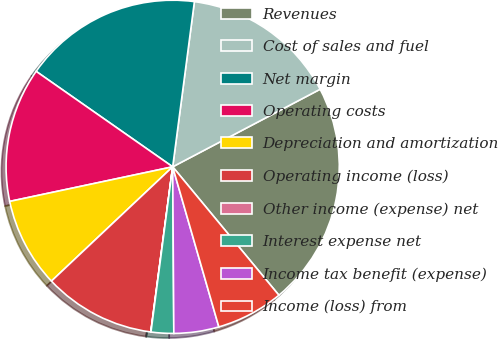Convert chart to OTSL. <chart><loc_0><loc_0><loc_500><loc_500><pie_chart><fcel>Revenues<fcel>Cost of sales and fuel<fcel>Net margin<fcel>Operating costs<fcel>Depreciation and amortization<fcel>Operating income (loss)<fcel>Other income (expense) net<fcel>Interest expense net<fcel>Income tax benefit (expense)<fcel>Income (loss) from<nl><fcel>21.71%<fcel>15.21%<fcel>17.37%<fcel>13.04%<fcel>8.7%<fcel>10.87%<fcel>0.02%<fcel>2.19%<fcel>4.36%<fcel>6.53%<nl></chart> 